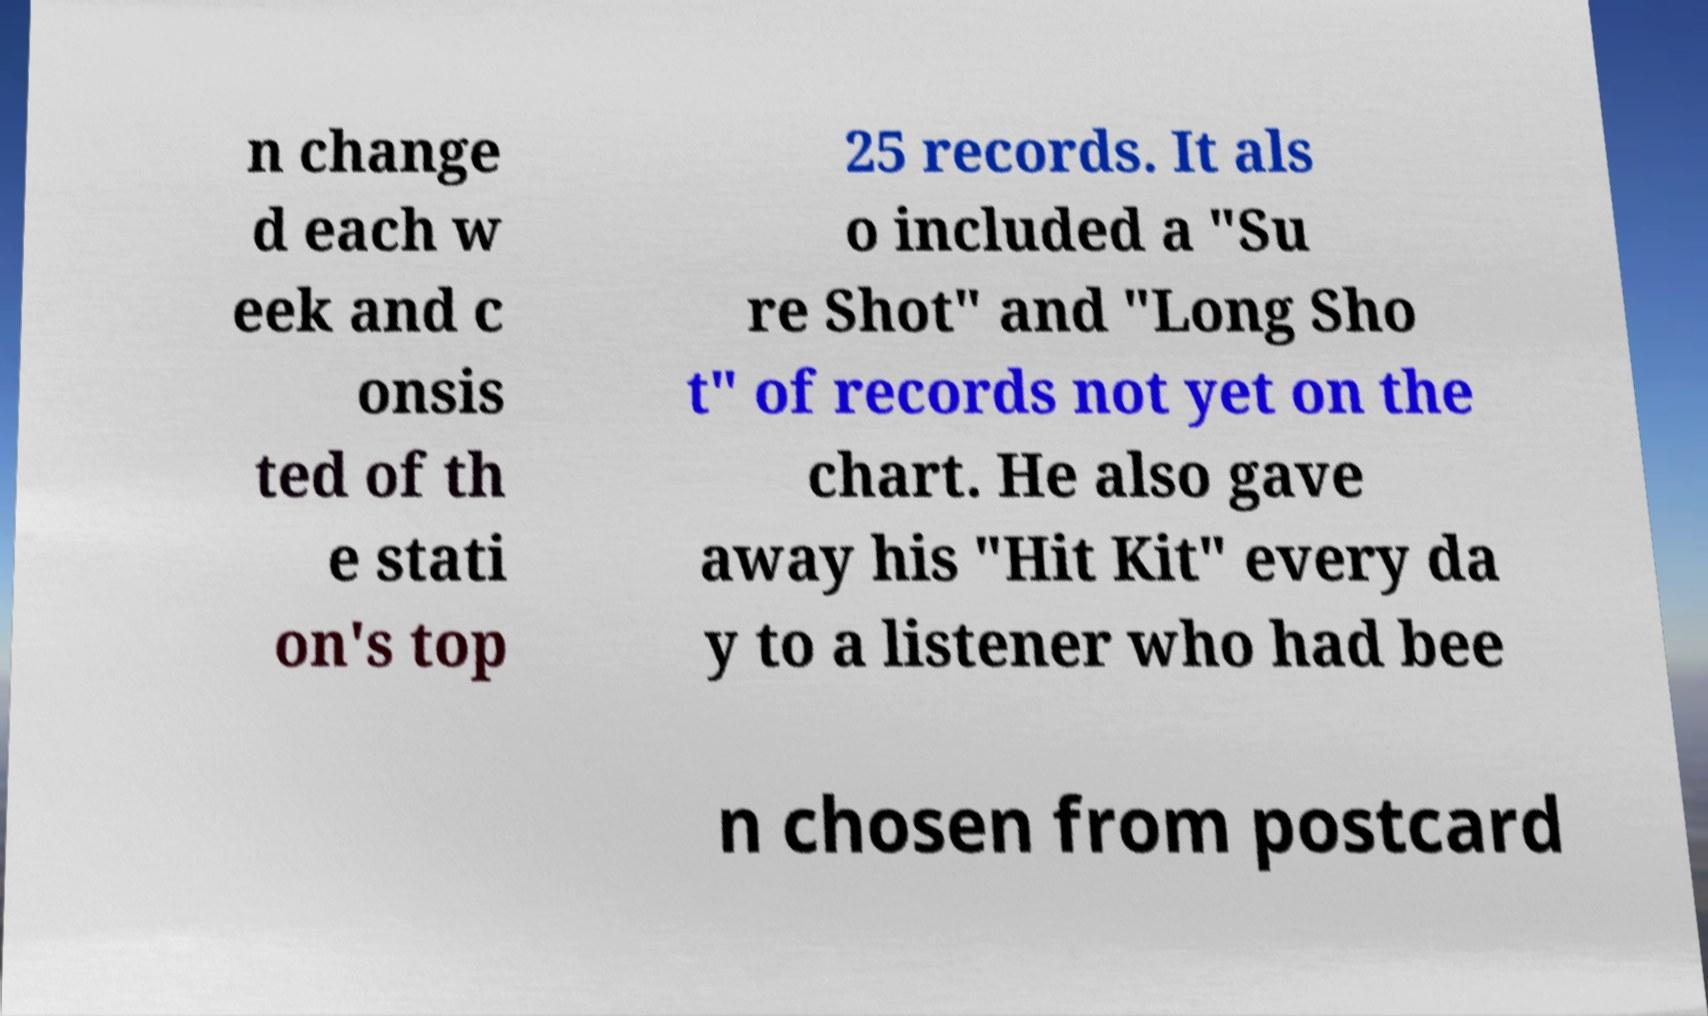Please identify and transcribe the text found in this image. n change d each w eek and c onsis ted of th e stati on's top 25 records. It als o included a "Su re Shot" and "Long Sho t" of records not yet on the chart. He also gave away his "Hit Kit" every da y to a listener who had bee n chosen from postcard 